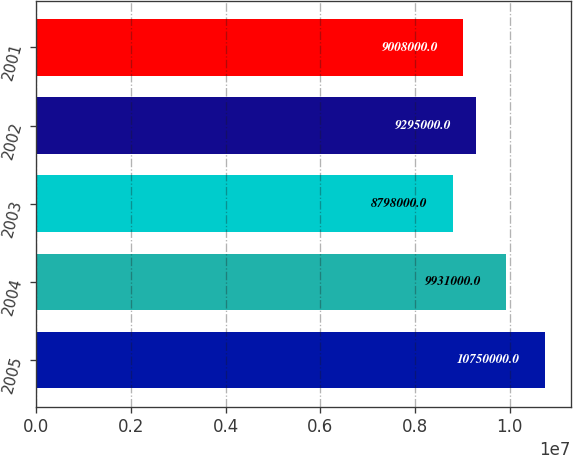Convert chart. <chart><loc_0><loc_0><loc_500><loc_500><bar_chart><fcel>2005<fcel>2004<fcel>2003<fcel>2002<fcel>2001<nl><fcel>1.075e+07<fcel>9.931e+06<fcel>8.798e+06<fcel>9.295e+06<fcel>9.008e+06<nl></chart> 